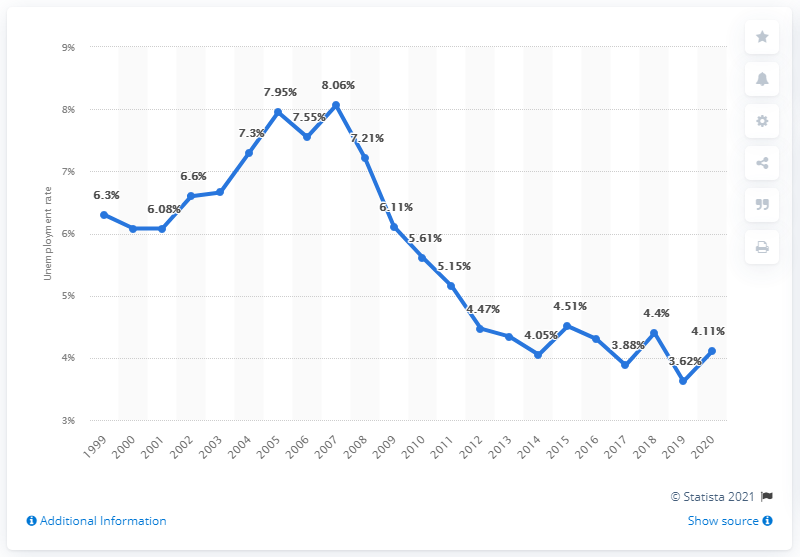Outline some significant characteristics in this image. The unemployment rate in Indonesia in 2020 was 4.11%. 